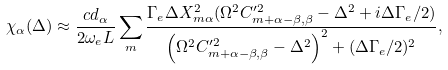<formula> <loc_0><loc_0><loc_500><loc_500>\chi _ { \alpha } ( \Delta ) \approx \frac { c d _ { \alpha } } { 2 \omega _ { e } L } \sum _ { m } \frac { \Gamma _ { e } \Delta X _ { m \alpha } ^ { 2 } ( \Omega ^ { 2 } C _ { m + \alpha - \beta , \beta } ^ { \prime 2 } - \Delta ^ { 2 } + i \Delta \Gamma _ { e } / 2 ) } { \left ( \Omega ^ { 2 } C _ { m + \alpha - \beta , \beta } ^ { \prime 2 } - \Delta ^ { 2 } \right ) ^ { 2 } + ( \Delta \Gamma _ { e } / 2 ) ^ { 2 } } ,</formula> 